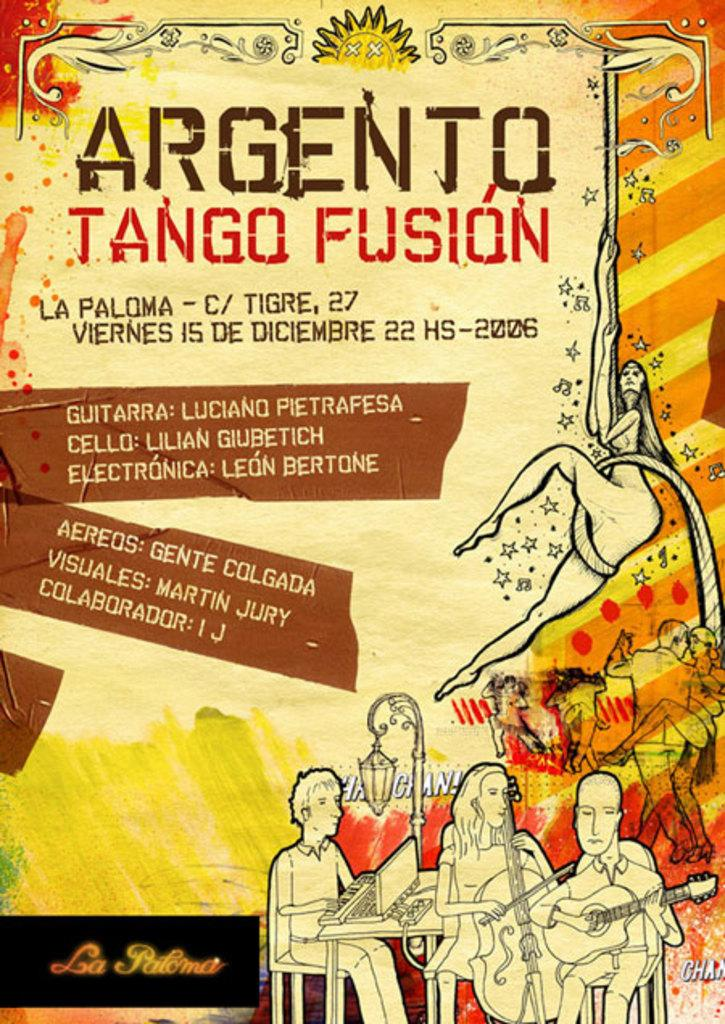<image>
Create a compact narrative representing the image presented. Poster for Argento Tango Fusion which takes place on the 27th. 